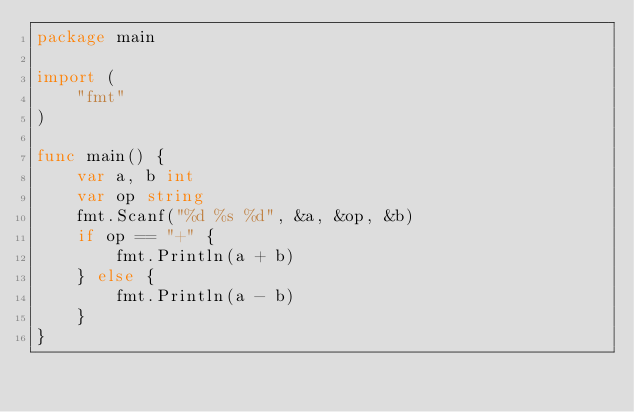<code> <loc_0><loc_0><loc_500><loc_500><_Go_>package main

import (
	"fmt"
)

func main() {
	var a, b int
	var op string
	fmt.Scanf("%d %s %d", &a, &op, &b)
	if op == "+" {
		fmt.Println(a + b)
	} else {
		fmt.Println(a - b)
	}
}
</code> 